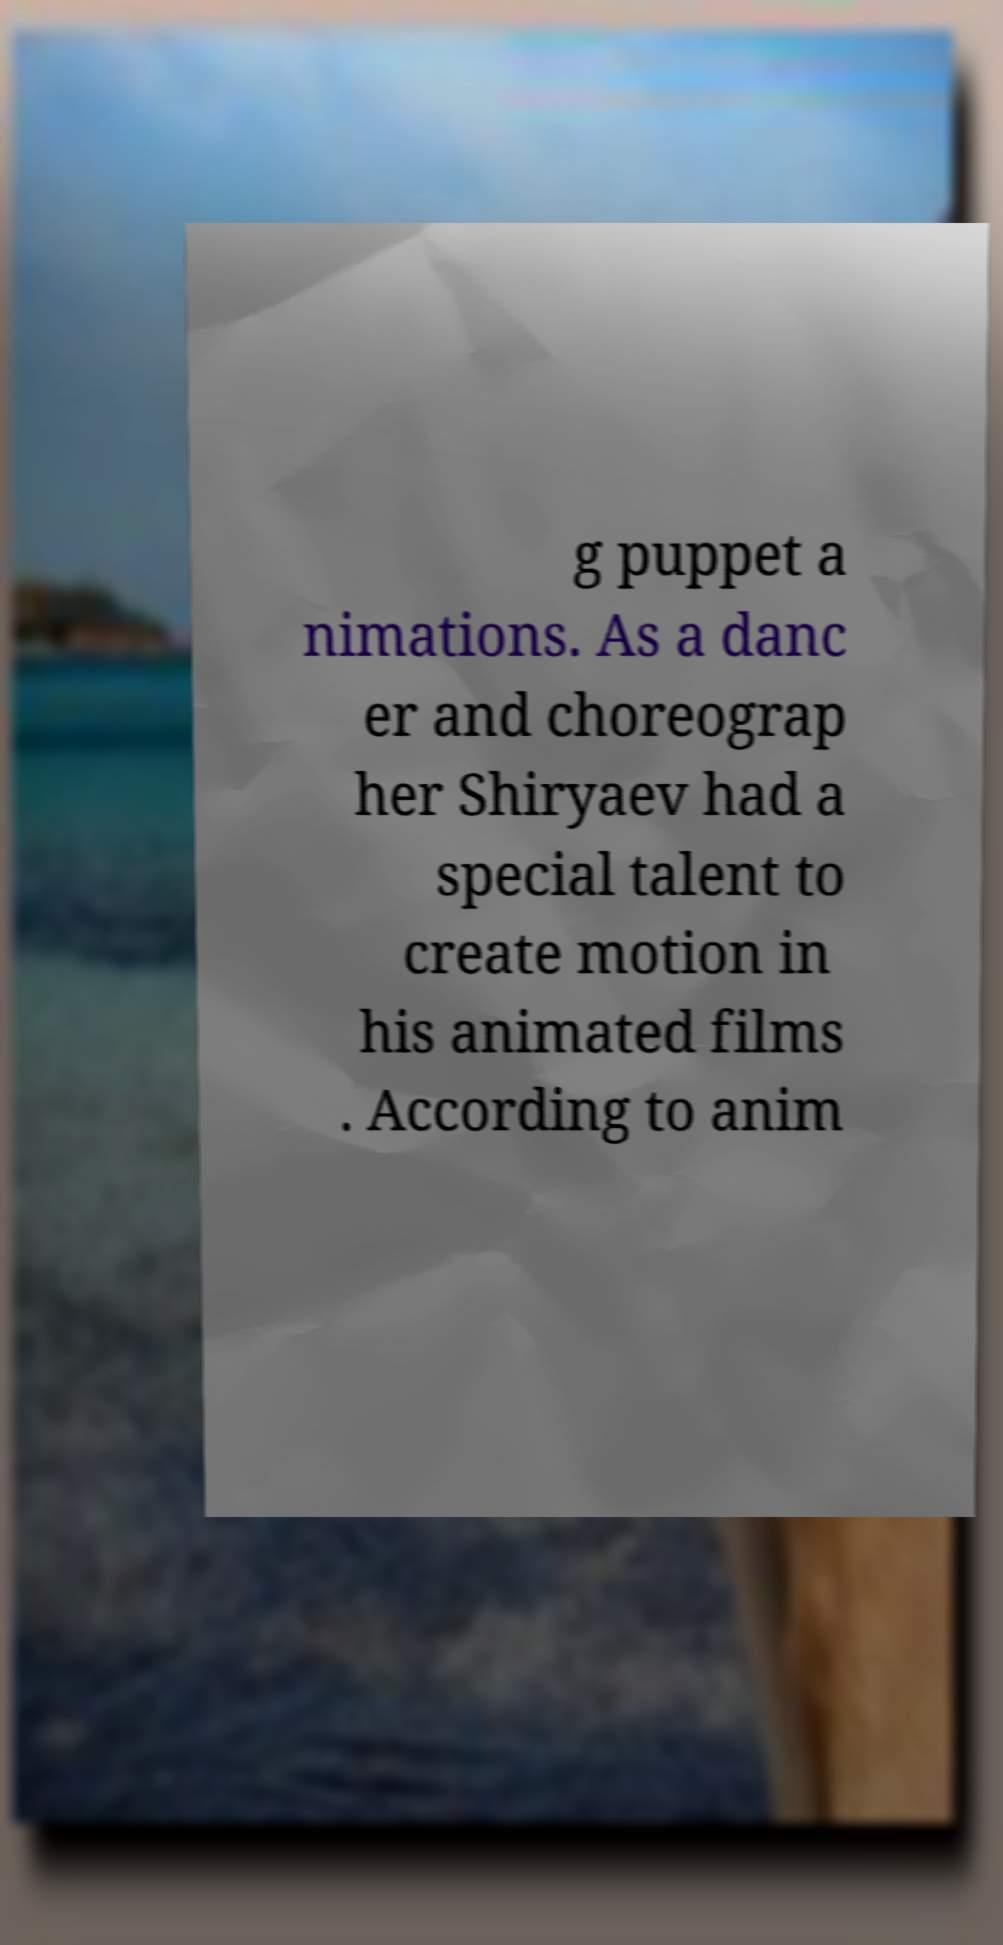There's text embedded in this image that I need extracted. Can you transcribe it verbatim? g puppet a nimations. As a danc er and choreograp her Shiryaev had a special talent to create motion in his animated films . According to anim 